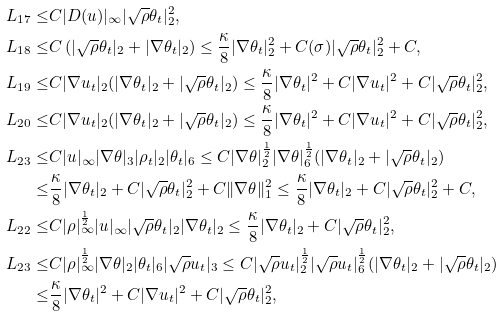Convert formula to latex. <formula><loc_0><loc_0><loc_500><loc_500>L _ { 1 7 } \leq & C | D ( u ) | _ { \infty } | \sqrt { \rho } \theta _ { t } | ^ { 2 } _ { 2 } , \\ L _ { 1 8 } \leq & C \left ( | \sqrt { \rho } \theta _ { t } | _ { 2 } + | \nabla \theta _ { t } | _ { 2 } \right ) \leq \frac { \kappa } { 8 } | \nabla \theta _ { t } | ^ { 2 } _ { 2 } + C ( \sigma ) | \sqrt { \rho } \theta _ { t } | ^ { 2 } _ { 2 } + C , \\ L _ { 1 9 } \leq & C | \nabla u _ { t } | _ { 2 } ( | \nabla \theta _ { t } | _ { 2 } + | \sqrt { \rho } \theta _ { t } | _ { 2 } ) \leq \frac { \kappa } { 8 } | \nabla \theta _ { t } | ^ { 2 } + C | \nabla u _ { t } | ^ { 2 } + C | \sqrt { \rho } \theta _ { t } | ^ { 2 } _ { 2 } , \\ L _ { 2 0 } \leq & C | \nabla u _ { t } | _ { 2 } ( | \nabla \theta _ { t } | _ { 2 } + | \sqrt { \rho } \theta _ { t } | _ { 2 } ) \leq \frac { \kappa } { 8 } | \nabla \theta _ { t } | ^ { 2 } + C | \nabla u _ { t } | ^ { 2 } + C | \sqrt { \rho } \theta _ { t } | ^ { 2 } _ { 2 } , \\ L _ { 2 3 } \leq & C | u | _ { \infty } | \nabla \theta | _ { 3 } | \rho _ { t } | _ { 2 } | \theta _ { t } | _ { 6 } \leq C | \nabla \theta | ^ { \frac { 1 } { 2 } } _ { 2 } | \nabla \theta | ^ { \frac { 1 } { 2 } } _ { 6 } ( | \nabla \theta _ { t } | _ { 2 } + | \sqrt { \rho } \theta _ { t } | _ { 2 } ) \\ \leq & \frac { \kappa } { 8 } | \nabla \theta _ { t } | _ { 2 } + C | \sqrt { \rho } \theta _ { t } | ^ { 2 } _ { 2 } + C \| \nabla \theta \| ^ { 2 } _ { 1 } \leq \frac { \kappa } { 8 } | \nabla \theta _ { t } | _ { 2 } + C | \sqrt { \rho } \theta _ { t } | ^ { 2 } _ { 2 } + C , \\ L _ { 2 2 } \leq & C | \rho | ^ { \frac { 1 } { 2 } } _ { \infty } | u | _ { \infty } | \sqrt { \rho } \theta _ { t } | _ { 2 } | \nabla \theta _ { t } | _ { 2 } \leq \frac { \kappa } { 8 } | \nabla \theta _ { t } | _ { 2 } + C | \sqrt { \rho } \theta _ { t } | ^ { 2 } _ { 2 } , \\ L _ { 2 3 } \leq & C | \rho | ^ { \frac { 1 } { 2 } } _ { \infty } | \nabla \theta | _ { 2 } | \theta _ { t } | _ { 6 } | \sqrt { \rho } u _ { t } | _ { 3 } \leq C | \sqrt { \rho } u _ { t } | ^ { \frac { 1 } { 2 } } _ { 2 } | \sqrt { \rho } u _ { t } | ^ { \frac { 1 } { 2 } } _ { 6 } ( | \nabla \theta _ { t } | _ { 2 } + | \sqrt { \rho } \theta _ { t } | _ { 2 } ) \\ \leq & \frac { \kappa } { 8 } | \nabla \theta _ { t } | ^ { 2 } + C | \nabla u _ { t } | ^ { 2 } + C | \sqrt { \rho } \theta _ { t } | ^ { 2 } _ { 2 } ,</formula> 